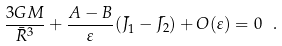Convert formula to latex. <formula><loc_0><loc_0><loc_500><loc_500>\frac { 3 G M } { \bar { R } ^ { 3 } } + \frac { A - B } { \varepsilon } ( \bar { J } _ { 1 } - \bar { J _ { 2 } } ) + O ( \varepsilon ) = 0 \ .</formula> 